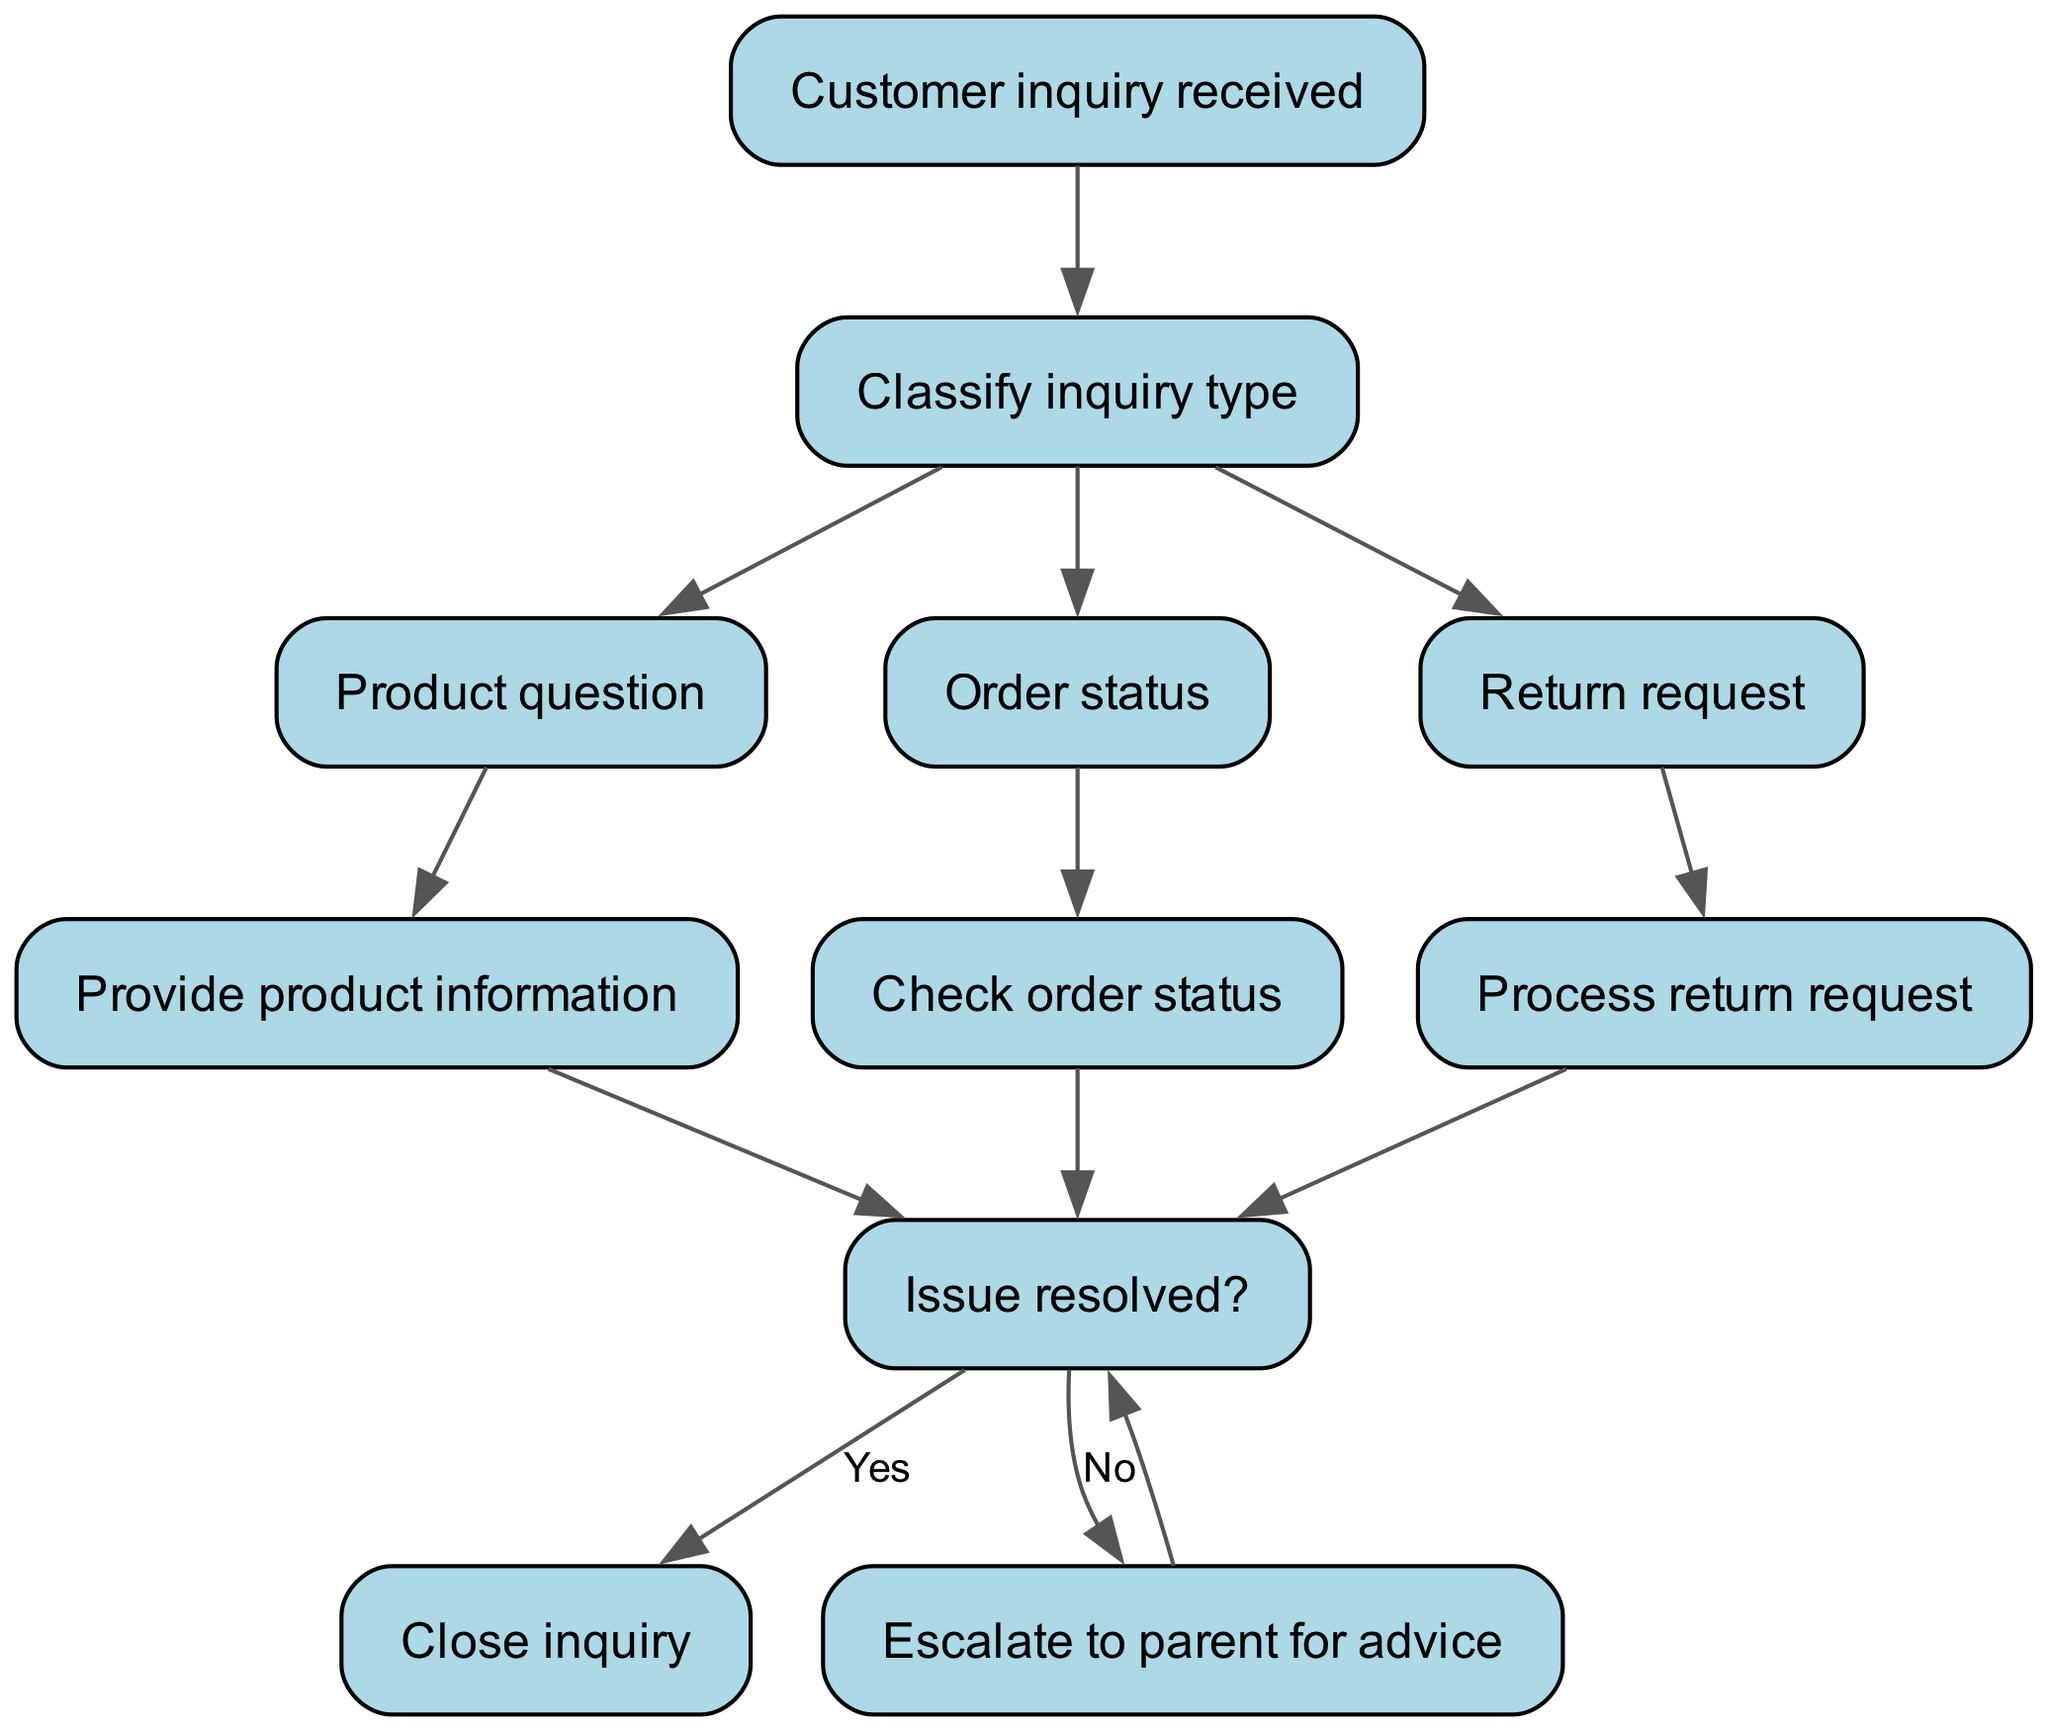What is the first step in the customer service process? The first step is the "Customer inquiry received" node, which indicates the initiation of the customer service process.
Answer: Customer inquiry received How many types of inquiries are classified in the diagram? The diagram shows three types of inquiries: "Product question", "Order status", and "Return request", which are all classified from the "Classify inquiry type" node.
Answer: Three Which node comes after "Check order status"? The node that comes after "Check order status" is "Issue resolved?" indicating a check to confirm if the customer's issue is resolved or not.
Answer: Issue resolved? If the issue is not resolved, where does the process lead? If the issue is not resolved, it leads to the node "Escalate to parent for advice", indicating that additional assistance is required.
Answer: Escalate to parent for advice What happens if the issue is resolved? If the issue is resolved, the process leads to "Close inquiry", which signifies the conclusion of the customer service interaction.
Answer: Close inquiry How many edges connect the nodes in the diagram? There are 11 edges in the diagram that indicate the flow of the process from one node to another.
Answer: Eleven Describe the purpose of the "Classify inquiry type" node. The "Classify inquiry type" node serves to categorize the incoming customer inquiry into specific types such as product questions, order statuses, or return requests, which helps streamline the service process.
Answer: Categorizing inquiries How does the flowchart show the resolution of an inquiry? The flowchart indicates resolution through the "Issue resolved?" node that leads to either "Close inquiry" if yes or "Escalate to parent for advice" if no, illustrating the decision-making process in customer service.
Answer: Decision-making process 